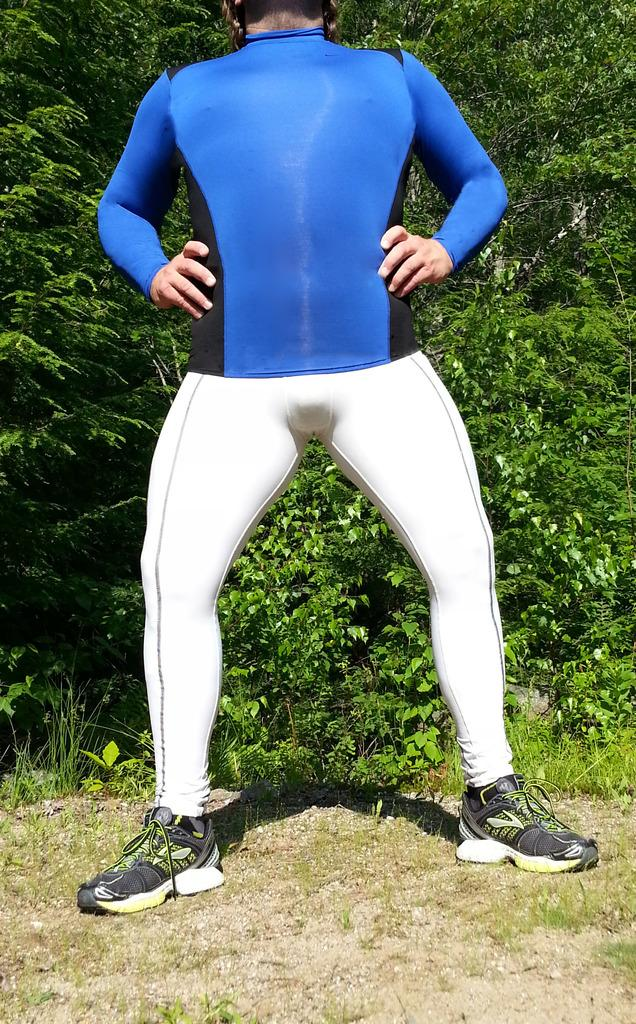What is the main subject of the image? There is a person in the image. What is the person wearing on their upper body? The person is wearing a blue t-shirt. What is the person wearing on their lower body? The person is wearing white pants. What type of footwear is the person wearing? The person is wearing sports shoes. Where is the person standing in the image? The person is standing on grassland. What can be seen in the background of the image? There are plants visible in the background of the image. What day of the week is it in the image? The day of the week is not mentioned or visible in the image. Is the person in the image biting into an apple? There is no apple or any indication of biting in the image. Can you see a zebra in the background of the image? There is no zebra present in the image; only plants are visible in the background. 